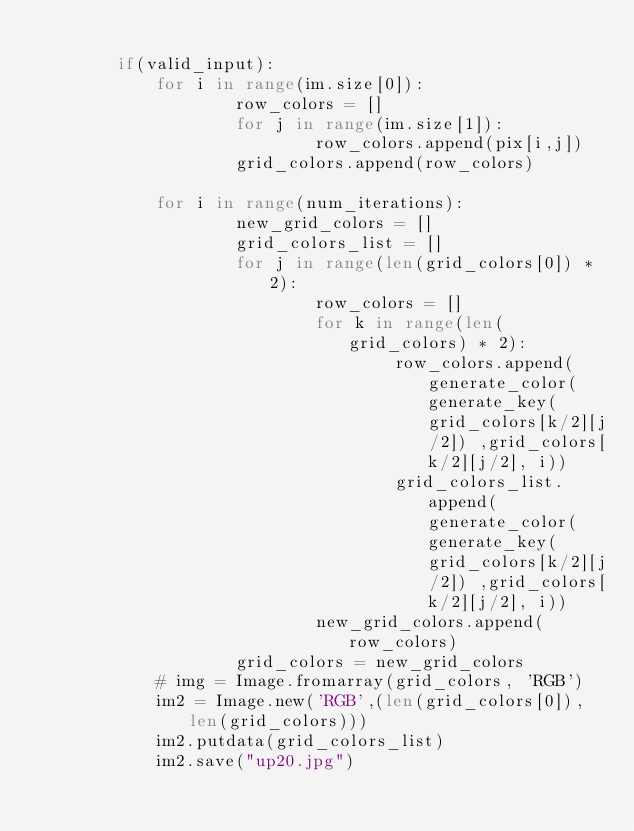Convert code to text. <code><loc_0><loc_0><loc_500><loc_500><_Python_>
        if(valid_input):
            for i in range(im.size[0]):
                    row_colors = []
                    for j in range(im.size[1]):
                            row_colors.append(pix[i,j])
                    grid_colors.append(row_colors)

            for i in range(num_iterations):
                    new_grid_colors = []
                    grid_colors_list = []
                    for j in range(len(grid_colors[0]) * 2):
                            row_colors = []
                            for k in range(len(grid_colors) * 2):
                                    row_colors.append(generate_color(generate_key(grid_colors[k/2][j/2]) ,grid_colors[k/2][j/2], i))
                                    grid_colors_list.append(generate_color(generate_key(grid_colors[k/2][j/2]) ,grid_colors[k/2][j/2], i))
                            new_grid_colors.append(row_colors)
                    grid_colors = new_grid_colors
            # img = Image.fromarray(grid_colors, 'RGB')
            im2 = Image.new('RGB',(len(grid_colors[0]),len(grid_colors)))
            im2.putdata(grid_colors_list)
            im2.save("up20.jpg")
</code> 